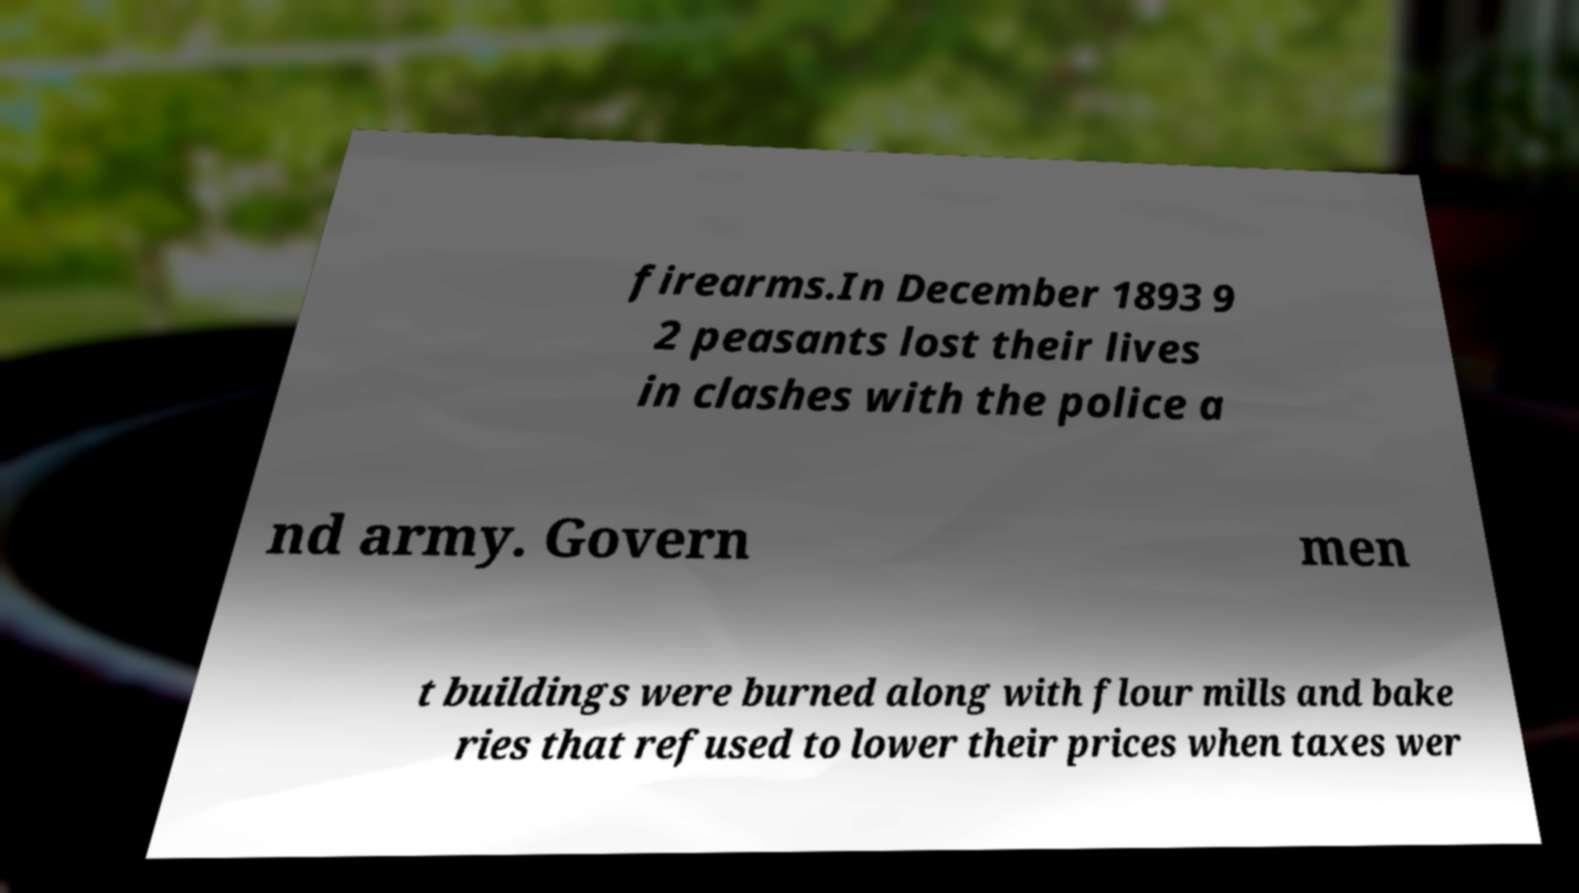Could you assist in decoding the text presented in this image and type it out clearly? firearms.In December 1893 9 2 peasants lost their lives in clashes with the police a nd army. Govern men t buildings were burned along with flour mills and bake ries that refused to lower their prices when taxes wer 